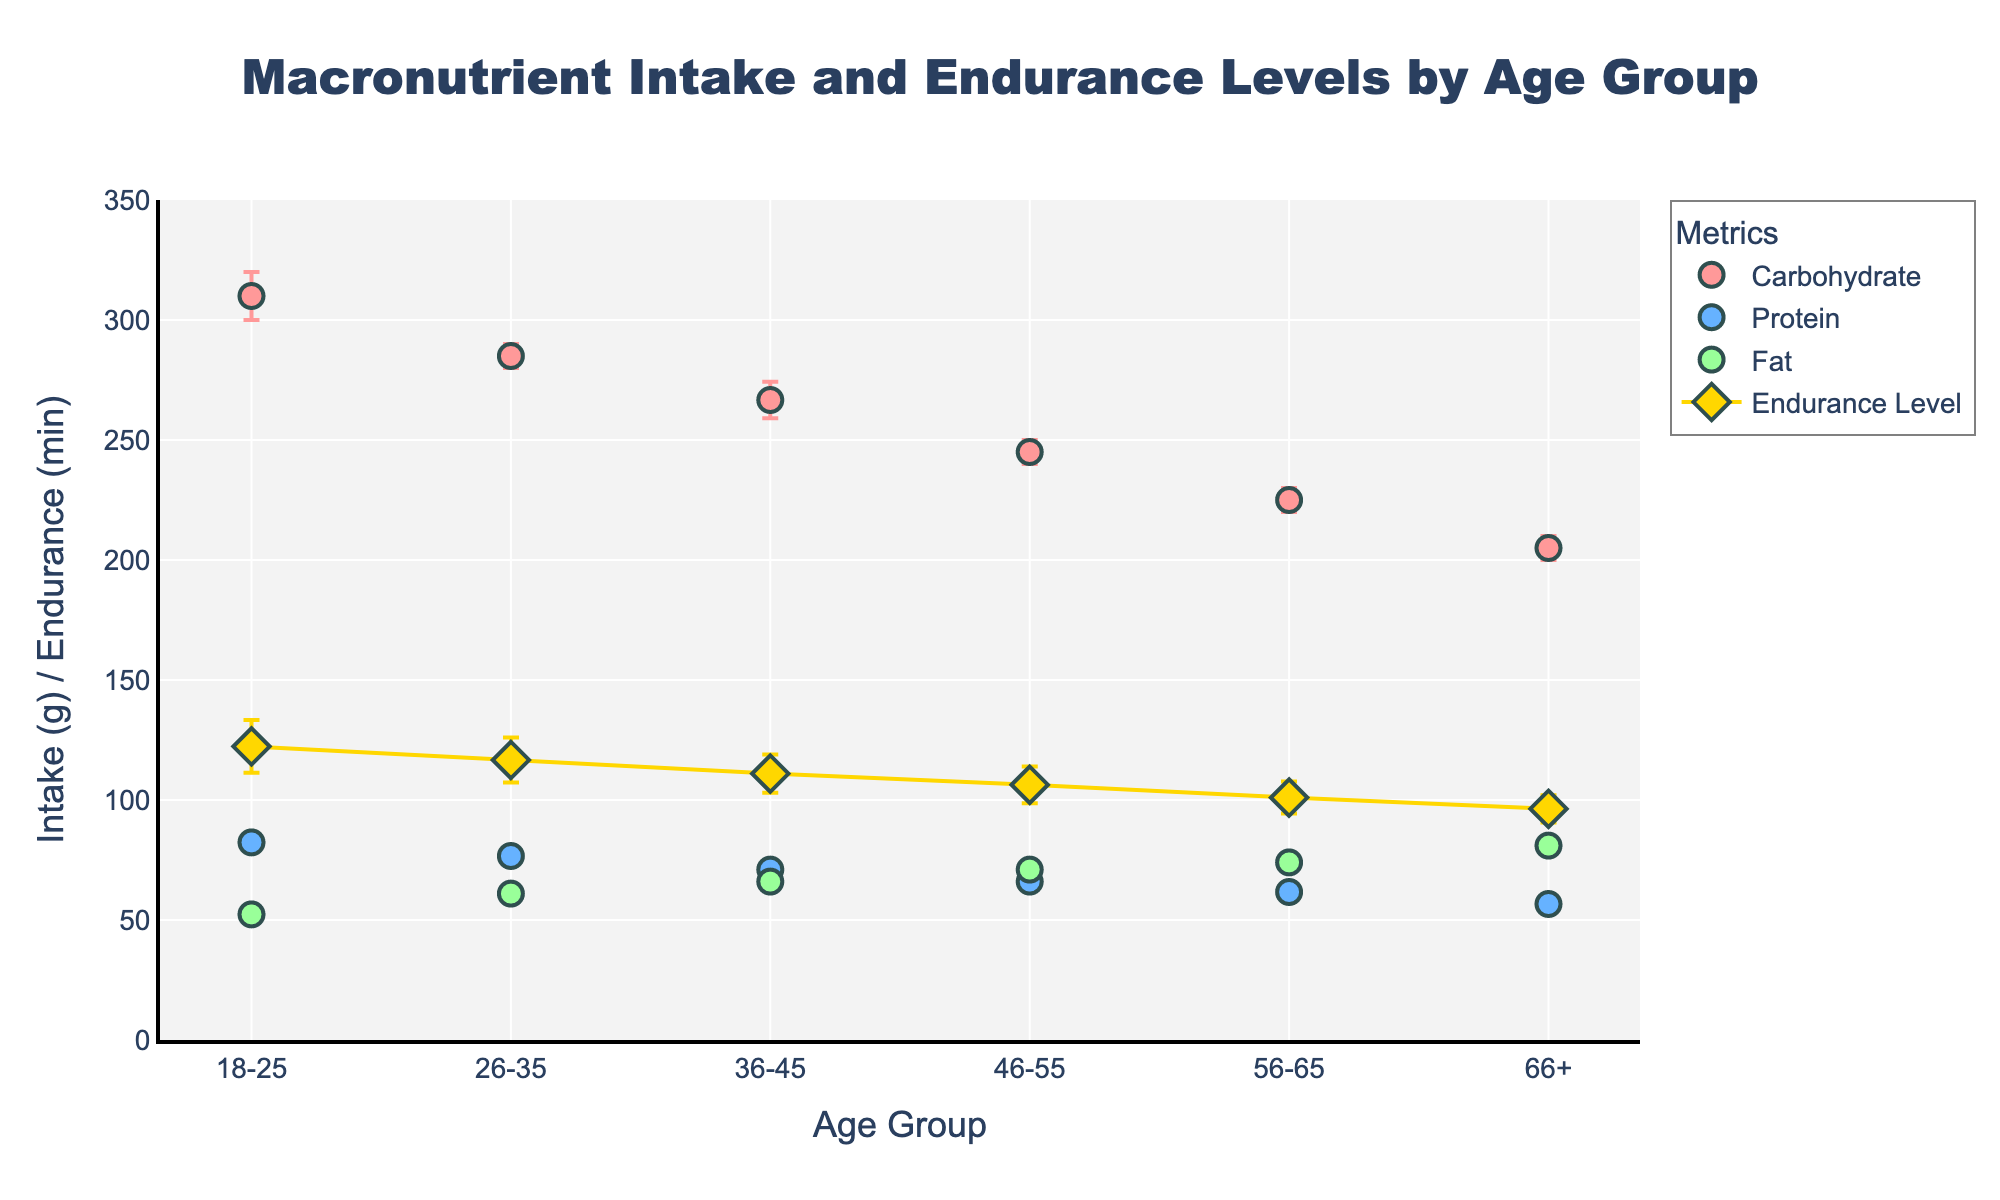Which age group has the highest average carbohydrate intake? By examining the scatter plot, we can see that the 18-25 age group has the highest average carbohydrate intake, indicated by the topmost marker in the carbohydrate category. The marker represents the average value among the different groups.
Answer: 18-25 What is the average protein intake for the 36-45 age group? Observing the scatter plot, we can see the marker for protein intake in the 36-45 age group. The marker shows the average protein intake in this age group. Looking at its position on the y-axis, it corresponds to approximately 71 grams.
Answer: 71 grams Which age group shows the smallest error in endurance level? The error bars around the endurance level markers indicate the variability in each age group. The smallest error bars are seen in the 66+ age group, indicating the least variability in their endurance levels.
Answer: 66+ How does the endurance level change with each successive age group? The endurance level is plotted with markers connected by lines. Observing the line’s trend, we can see that the endurance level decreases progressively in each successive age group.
Answer: Decreases Which macronutrient shows the greatest variability in the 26-35 age group? The variability is represented by the length of error bars. For the 26-35 age group, the carbohydrate intake has the longest error bars, which means it has the greatest variability compared to protein and fat.
Answer: Carbohydrate What is the average endurance level for the 46-55 age group? By examining the marker representing the endurance level for the 46-55 age group, we can see its position on the y-axis. This marker corresponds to approximately 106 minutes.
Answer: 106 minutes Compare the fat intake of the 18-25 age group with the 66+ age group. Observing the scatter plot, we can compare the markers representing fat intake for both the 18-25 and 66+ age groups. The 18-25 age group has a fat intake around 52-55 grams, while the 66+ age group has fat intake around 80-82 grams. The 66+ age group has a significantly higher fat intake.
Answer: Higher in 66+ Which nutrient intake shows an increasing trend as the age group increases? By observing the trend of each nutrient intake across age groups, we see that the fat intake marker positions rise progressively from younger to older age groups, indicating an increasing trend in fat intake with age.
Answer: Fat What is the approximate drop in endurance level from the 18-25 age group to the 66+ age group? The endurance level marker for the 18-25 age group is around 122 minutes, and for the 66+ age group, it is around 96 minutes. The approximate drop is 122 - 96 = 26 minutes.
Answer: 26 minutes 